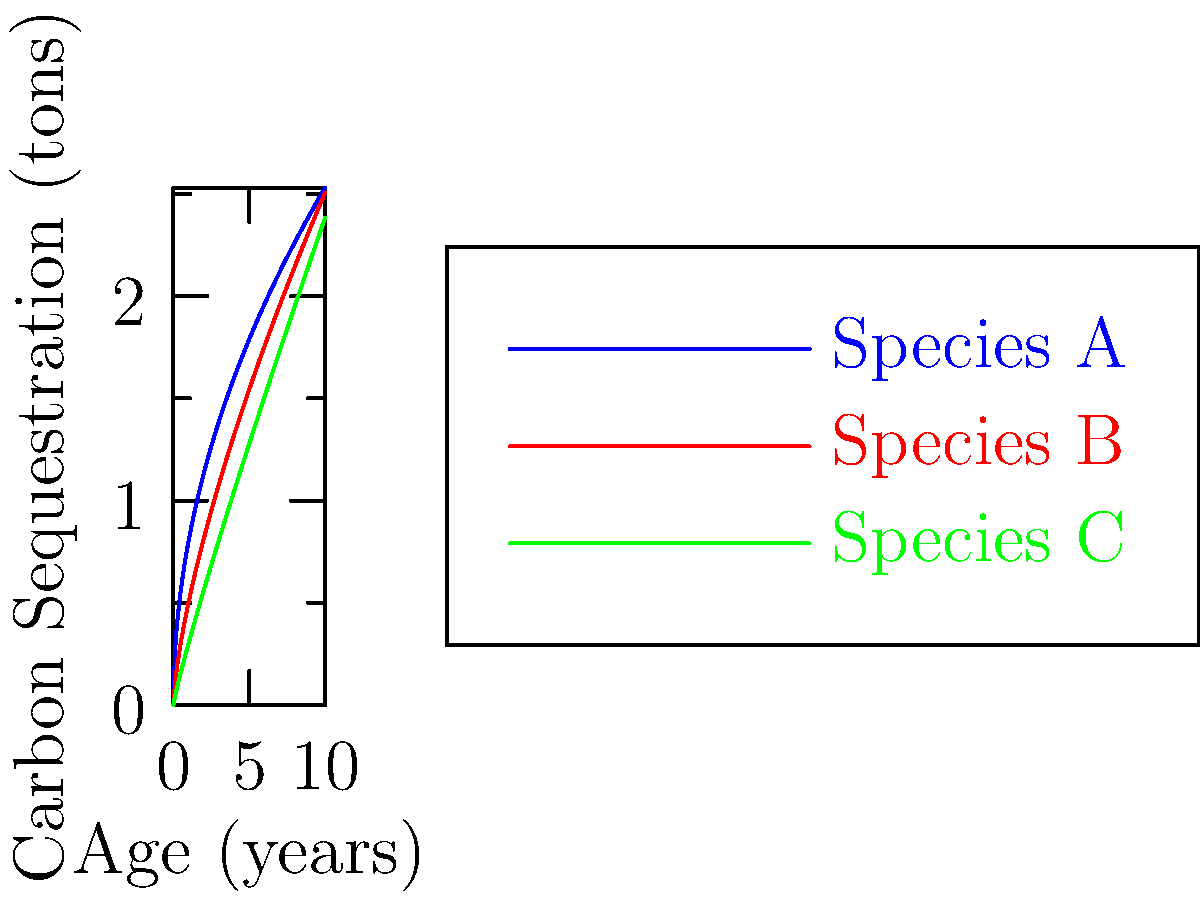Based on the growth curves shown in the graph, which tree species would you recommend for a reforestation project aimed at maximizing carbon sequestration over a 10-year period? Justify your answer using the concept of area under the curve. To determine which species would maximize carbon sequestration over a 10-year period, we need to compare the areas under each curve from 0 to 10 years. The area under each curve represents the total carbon sequestered over time.

Step 1: Analyze the curve shapes
- Species A (blue): Rapid initial growth, then slowing
- Species B (red): Moderate, steady growth
- Species C (green): Slow initial growth, then accelerating

Step 2: Estimate area under each curve
While we can't calculate exact areas without integration, we can visually estimate:
- Species A has the largest area under its curve
- Species B has the second-largest area
- Species C has the smallest area

Step 3: Consider long-term potential
Although not part of the 10-year question, note that Species C shows potential for higher sequestration beyond the 10-year mark.

Step 4: Make a recommendation
Based on the largest area under the curve over the 10-year period, Species A would be the best choice for maximizing carbon sequestration in this timeframe.

Step 5: Relate to forestry practice
As an experienced forester, you might recognize that fast-growing pioneer species often exhibit growth patterns similar to Species A, making them valuable for rapid carbon sequestration in reforestation projects.
Answer: Species A, due to largest area under curve over 10 years. 